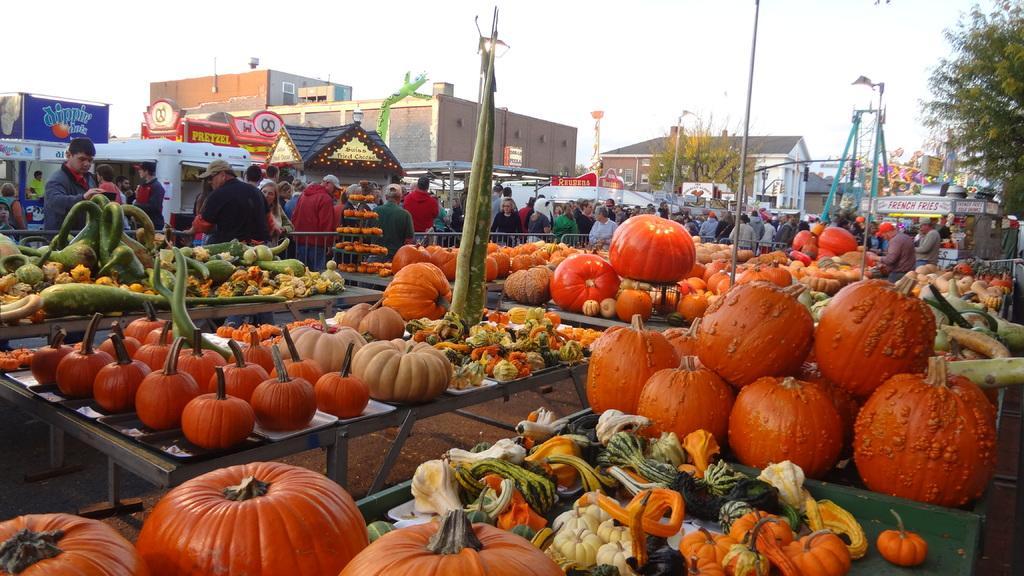Could you give a brief overview of what you see in this image? In this picture there are pumpkins and vegetables on the tables. At the back there are group of people behind the railing and there are buildings and trees and poles and there are boards on the buildings and there is text on the boards. At the top there is sky. At the bottom there is a road. 